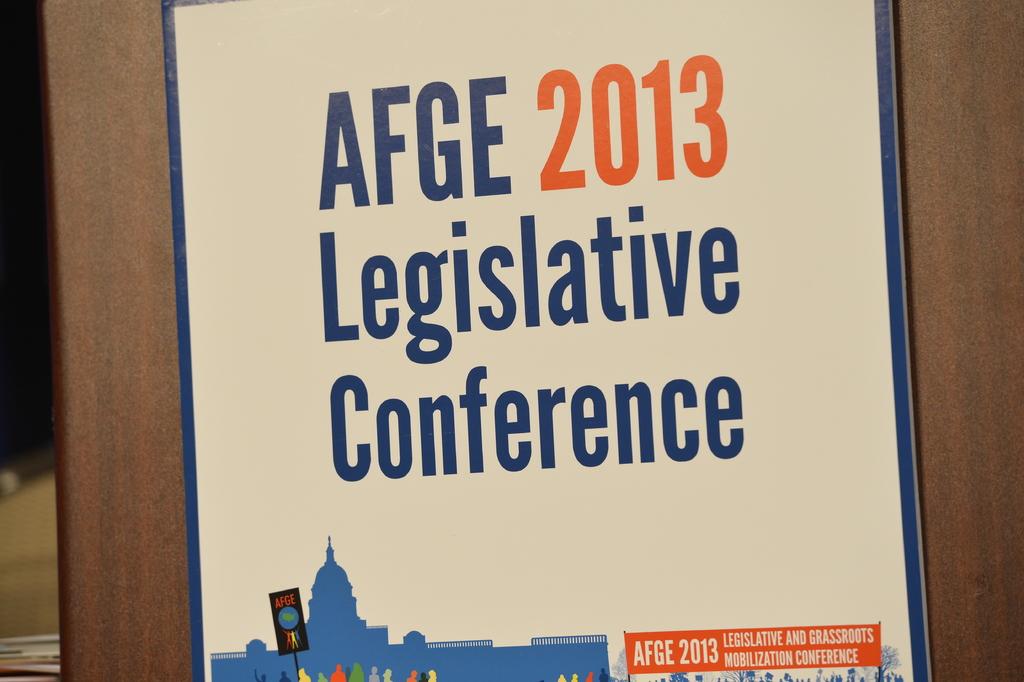What year is the legislative conference?
Provide a succinct answer. 2013. Who is sponsoring this conference?
Give a very brief answer. Afge. 